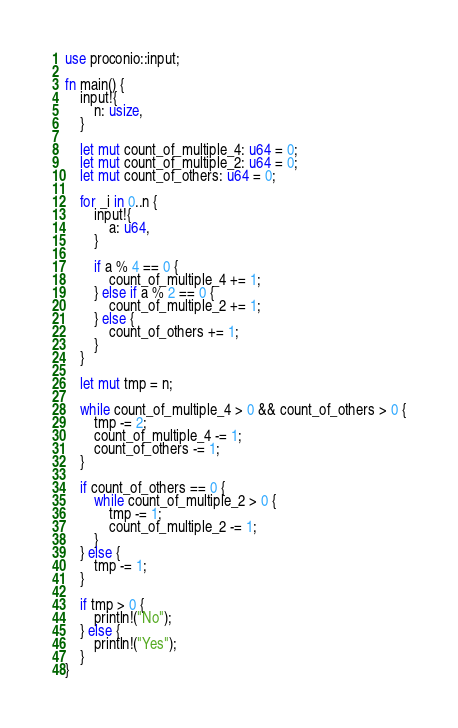<code> <loc_0><loc_0><loc_500><loc_500><_Rust_>use proconio::input;

fn main() {
    input!{
        n: usize,
    }

    let mut count_of_multiple_4: u64 = 0;
    let mut count_of_multiple_2: u64 = 0;
    let mut count_of_others: u64 = 0;

    for _i in 0..n {
        input!{
            a: u64,
        }

        if a % 4 == 0 {
            count_of_multiple_4 += 1;
        } else if a % 2 == 0 {
            count_of_multiple_2 += 1;
        } else {
            count_of_others += 1;
        }
    }

    let mut tmp = n;

    while count_of_multiple_4 > 0 && count_of_others > 0 {
        tmp -= 2;
        count_of_multiple_4 -= 1;
        count_of_others -= 1;
    }

    if count_of_others == 0 {
        while count_of_multiple_2 > 0 {
            tmp -= 1;
            count_of_multiple_2 -= 1;
        }
    } else {
        tmp -= 1;
    }

    if tmp > 0 {
        println!("No");
    } else {
        println!("Yes");
    }
}
</code> 